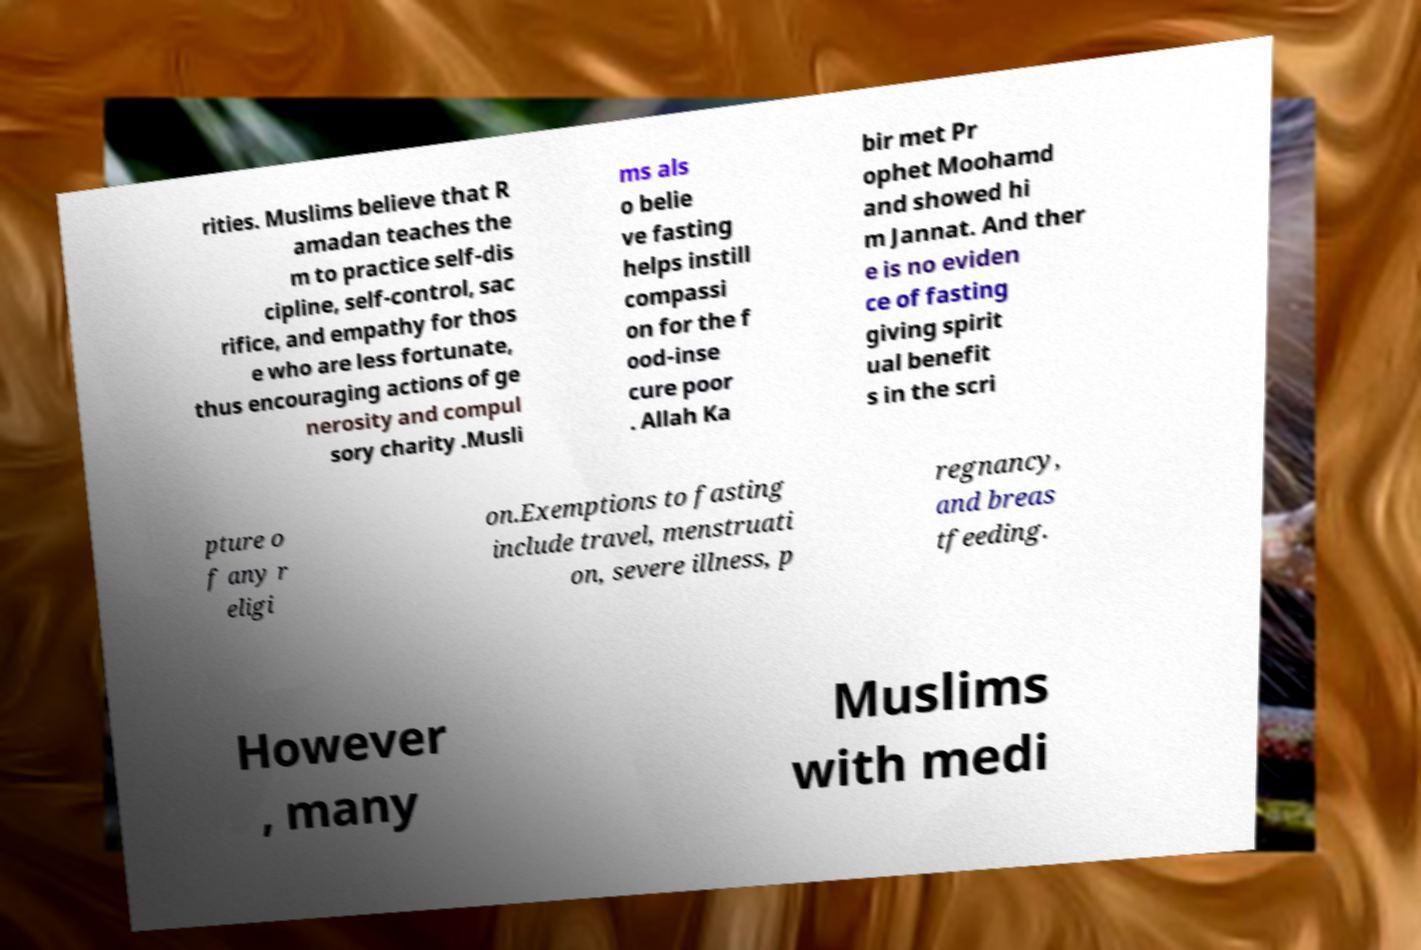Please identify and transcribe the text found in this image. rities. Muslims believe that R amadan teaches the m to practice self-dis cipline, self-control, sac rifice, and empathy for thos e who are less fortunate, thus encouraging actions of ge nerosity and compul sory charity .Musli ms als o belie ve fasting helps instill compassi on for the f ood-inse cure poor . Allah Ka bir met Pr ophet Moohamd and showed hi m Jannat. And ther e is no eviden ce of fasting giving spirit ual benefit s in the scri pture o f any r eligi on.Exemptions to fasting include travel, menstruati on, severe illness, p regnancy, and breas tfeeding. However , many Muslims with medi 